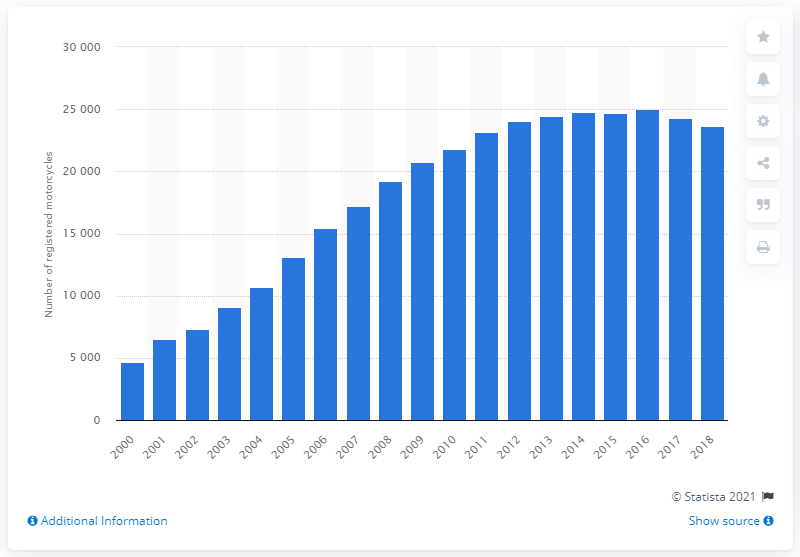List a handful of essential elements in this visual. In 2000, there were 4,681 Piaggio Vespa motorcycles in Great Britain. In 2018, there were 23,658 Piaggio Vespa motorcycles in Great Britain. 